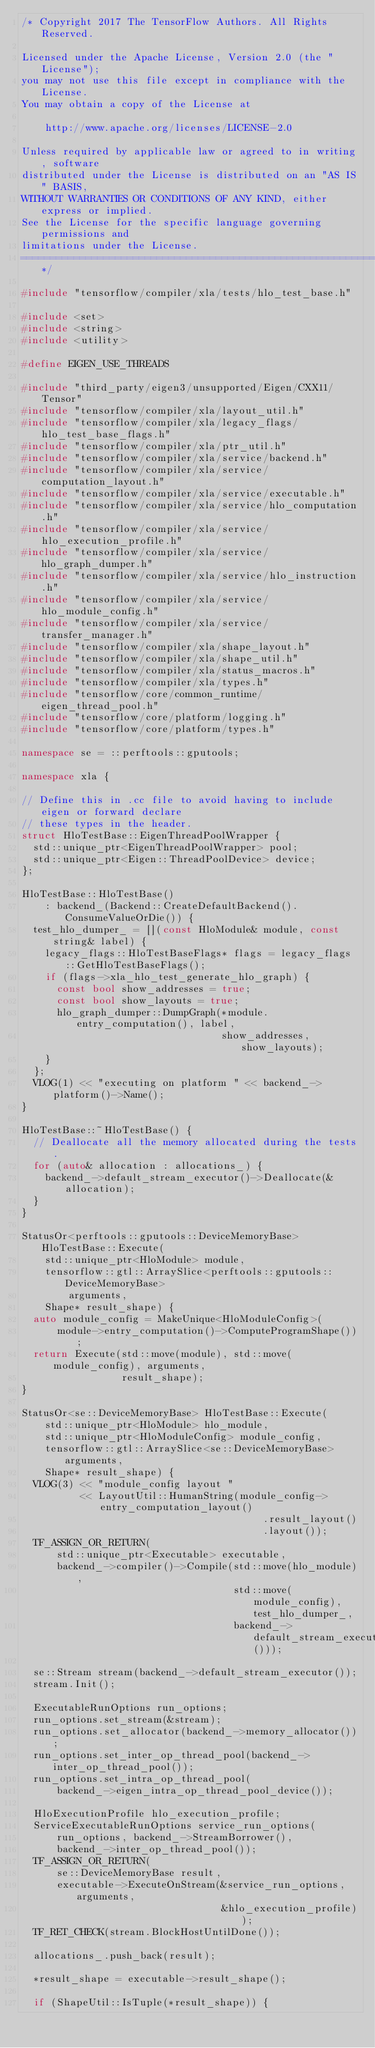Convert code to text. <code><loc_0><loc_0><loc_500><loc_500><_C++_>/* Copyright 2017 The TensorFlow Authors. All Rights Reserved.

Licensed under the Apache License, Version 2.0 (the "License");
you may not use this file except in compliance with the License.
You may obtain a copy of the License at

    http://www.apache.org/licenses/LICENSE-2.0

Unless required by applicable law or agreed to in writing, software
distributed under the License is distributed on an "AS IS" BASIS,
WITHOUT WARRANTIES OR CONDITIONS OF ANY KIND, either express or implied.
See the License for the specific language governing permissions and
limitations under the License.
==============================================================================*/

#include "tensorflow/compiler/xla/tests/hlo_test_base.h"

#include <set>
#include <string>
#include <utility>

#define EIGEN_USE_THREADS

#include "third_party/eigen3/unsupported/Eigen/CXX11/Tensor"
#include "tensorflow/compiler/xla/layout_util.h"
#include "tensorflow/compiler/xla/legacy_flags/hlo_test_base_flags.h"
#include "tensorflow/compiler/xla/ptr_util.h"
#include "tensorflow/compiler/xla/service/backend.h"
#include "tensorflow/compiler/xla/service/computation_layout.h"
#include "tensorflow/compiler/xla/service/executable.h"
#include "tensorflow/compiler/xla/service/hlo_computation.h"
#include "tensorflow/compiler/xla/service/hlo_execution_profile.h"
#include "tensorflow/compiler/xla/service/hlo_graph_dumper.h"
#include "tensorflow/compiler/xla/service/hlo_instruction.h"
#include "tensorflow/compiler/xla/service/hlo_module_config.h"
#include "tensorflow/compiler/xla/service/transfer_manager.h"
#include "tensorflow/compiler/xla/shape_layout.h"
#include "tensorflow/compiler/xla/shape_util.h"
#include "tensorflow/compiler/xla/status_macros.h"
#include "tensorflow/compiler/xla/types.h"
#include "tensorflow/core/common_runtime/eigen_thread_pool.h"
#include "tensorflow/core/platform/logging.h"
#include "tensorflow/core/platform/types.h"

namespace se = ::perftools::gputools;

namespace xla {

// Define this in .cc file to avoid having to include eigen or forward declare
// these types in the header.
struct HloTestBase::EigenThreadPoolWrapper {
  std::unique_ptr<EigenThreadPoolWrapper> pool;
  std::unique_ptr<Eigen::ThreadPoolDevice> device;
};

HloTestBase::HloTestBase()
    : backend_(Backend::CreateDefaultBackend().ConsumeValueOrDie()) {
  test_hlo_dumper_ = [](const HloModule& module, const string& label) {
    legacy_flags::HloTestBaseFlags* flags = legacy_flags::GetHloTestBaseFlags();
    if (flags->xla_hlo_test_generate_hlo_graph) {
      const bool show_addresses = true;
      const bool show_layouts = true;
      hlo_graph_dumper::DumpGraph(*module.entry_computation(), label,
                                  show_addresses, show_layouts);
    }
  };
  VLOG(1) << "executing on platform " << backend_->platform()->Name();
}

HloTestBase::~HloTestBase() {
  // Deallocate all the memory allocated during the tests.
  for (auto& allocation : allocations_) {
    backend_->default_stream_executor()->Deallocate(&allocation);
  }
}

StatusOr<perftools::gputools::DeviceMemoryBase> HloTestBase::Execute(
    std::unique_ptr<HloModule> module,
    tensorflow::gtl::ArraySlice<perftools::gputools::DeviceMemoryBase>
        arguments,
    Shape* result_shape) {
  auto module_config = MakeUnique<HloModuleConfig>(
      module->entry_computation()->ComputeProgramShape());
  return Execute(std::move(module), std::move(module_config), arguments,
                 result_shape);
}

StatusOr<se::DeviceMemoryBase> HloTestBase::Execute(
    std::unique_ptr<HloModule> hlo_module,
    std::unique_ptr<HloModuleConfig> module_config,
    tensorflow::gtl::ArraySlice<se::DeviceMemoryBase> arguments,
    Shape* result_shape) {
  VLOG(3) << "module_config layout "
          << LayoutUtil::HumanString(module_config->entry_computation_layout()
                                         .result_layout()
                                         .layout());
  TF_ASSIGN_OR_RETURN(
      std::unique_ptr<Executable> executable,
      backend_->compiler()->Compile(std::move(hlo_module),
                                    std::move(module_config), test_hlo_dumper_,
                                    backend_->default_stream_executor()));

  se::Stream stream(backend_->default_stream_executor());
  stream.Init();

  ExecutableRunOptions run_options;
  run_options.set_stream(&stream);
  run_options.set_allocator(backend_->memory_allocator());
  run_options.set_inter_op_thread_pool(backend_->inter_op_thread_pool());
  run_options.set_intra_op_thread_pool(
      backend_->eigen_intra_op_thread_pool_device());

  HloExecutionProfile hlo_execution_profile;
  ServiceExecutableRunOptions service_run_options(
      run_options, backend_->StreamBorrower(),
      backend_->inter_op_thread_pool());
  TF_ASSIGN_OR_RETURN(
      se::DeviceMemoryBase result,
      executable->ExecuteOnStream(&service_run_options, arguments,
                                  &hlo_execution_profile));
  TF_RET_CHECK(stream.BlockHostUntilDone());

  allocations_.push_back(result);

  *result_shape = executable->result_shape();

  if (ShapeUtil::IsTuple(*result_shape)) {</code> 